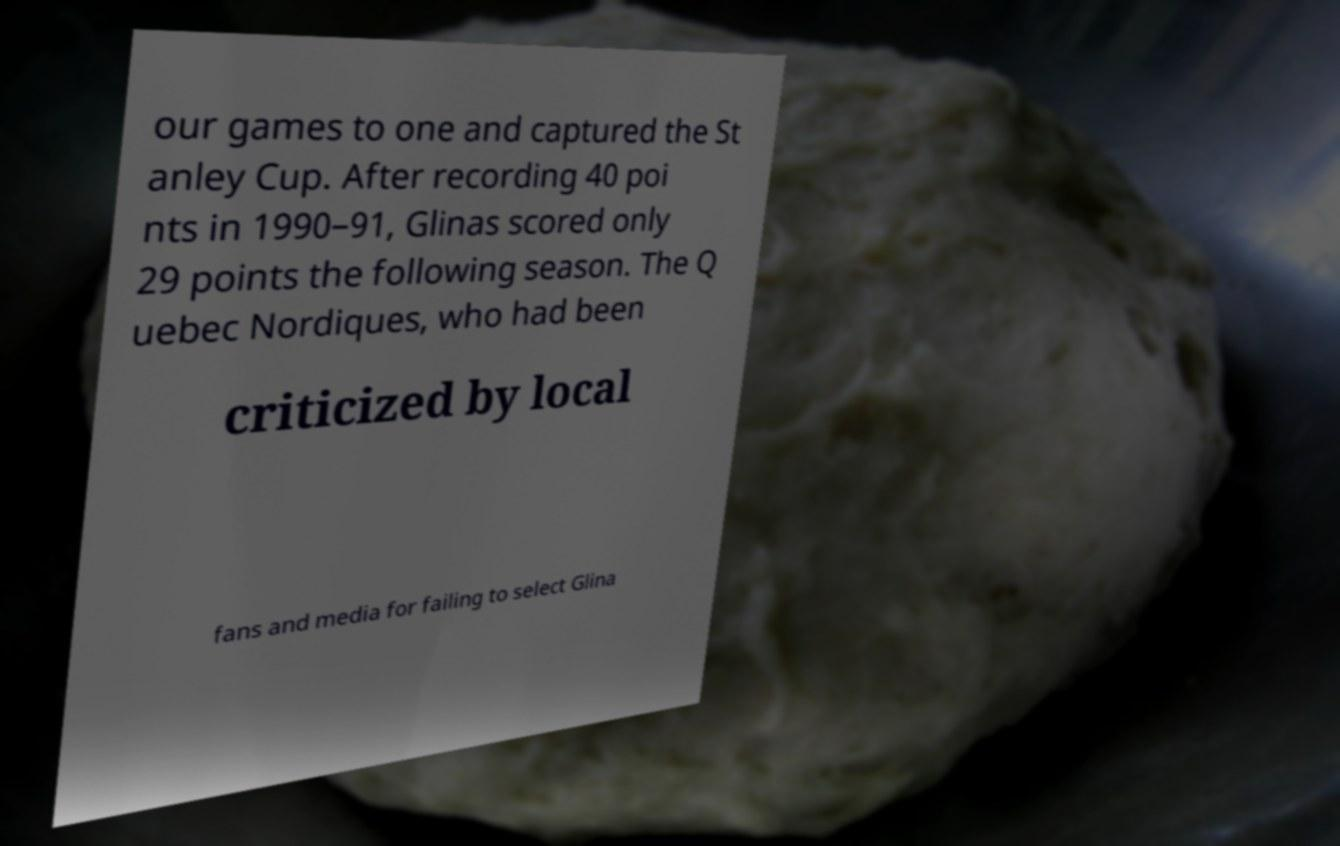There's text embedded in this image that I need extracted. Can you transcribe it verbatim? our games to one and captured the St anley Cup. After recording 40 poi nts in 1990–91, Glinas scored only 29 points the following season. The Q uebec Nordiques, who had been criticized by local fans and media for failing to select Glina 